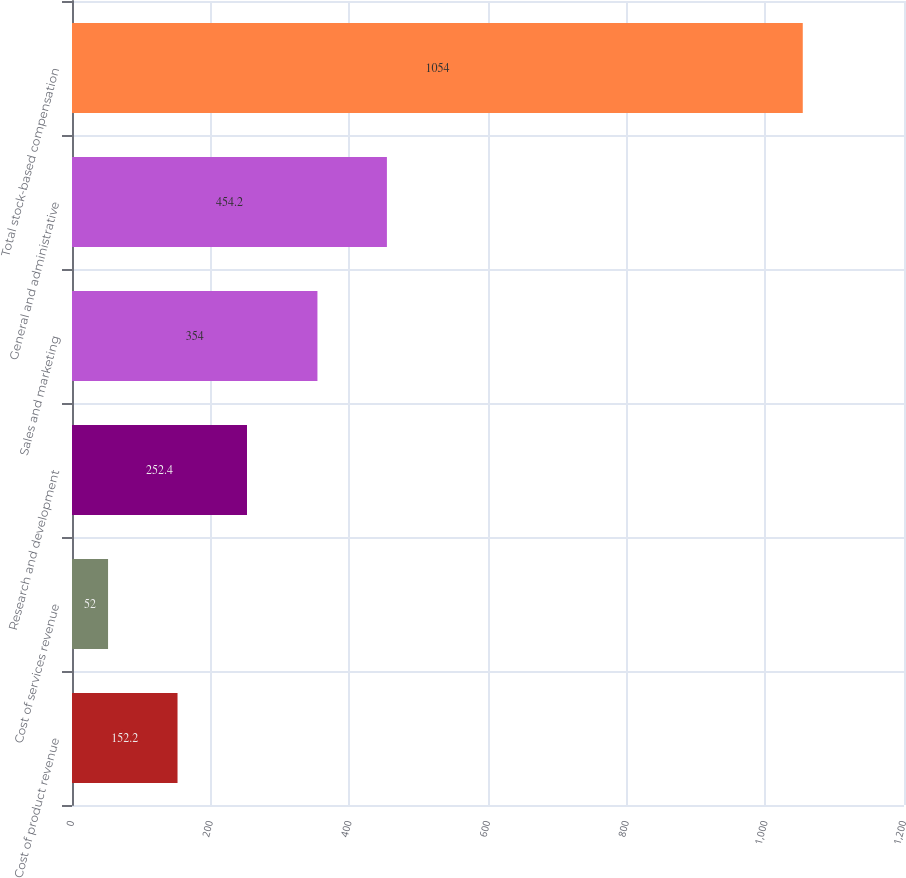Convert chart. <chart><loc_0><loc_0><loc_500><loc_500><bar_chart><fcel>Cost of product revenue<fcel>Cost of services revenue<fcel>Research and development<fcel>Sales and marketing<fcel>General and administrative<fcel>Total stock-based compensation<nl><fcel>152.2<fcel>52<fcel>252.4<fcel>354<fcel>454.2<fcel>1054<nl></chart> 